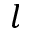Convert formula to latex. <formula><loc_0><loc_0><loc_500><loc_500>l</formula> 